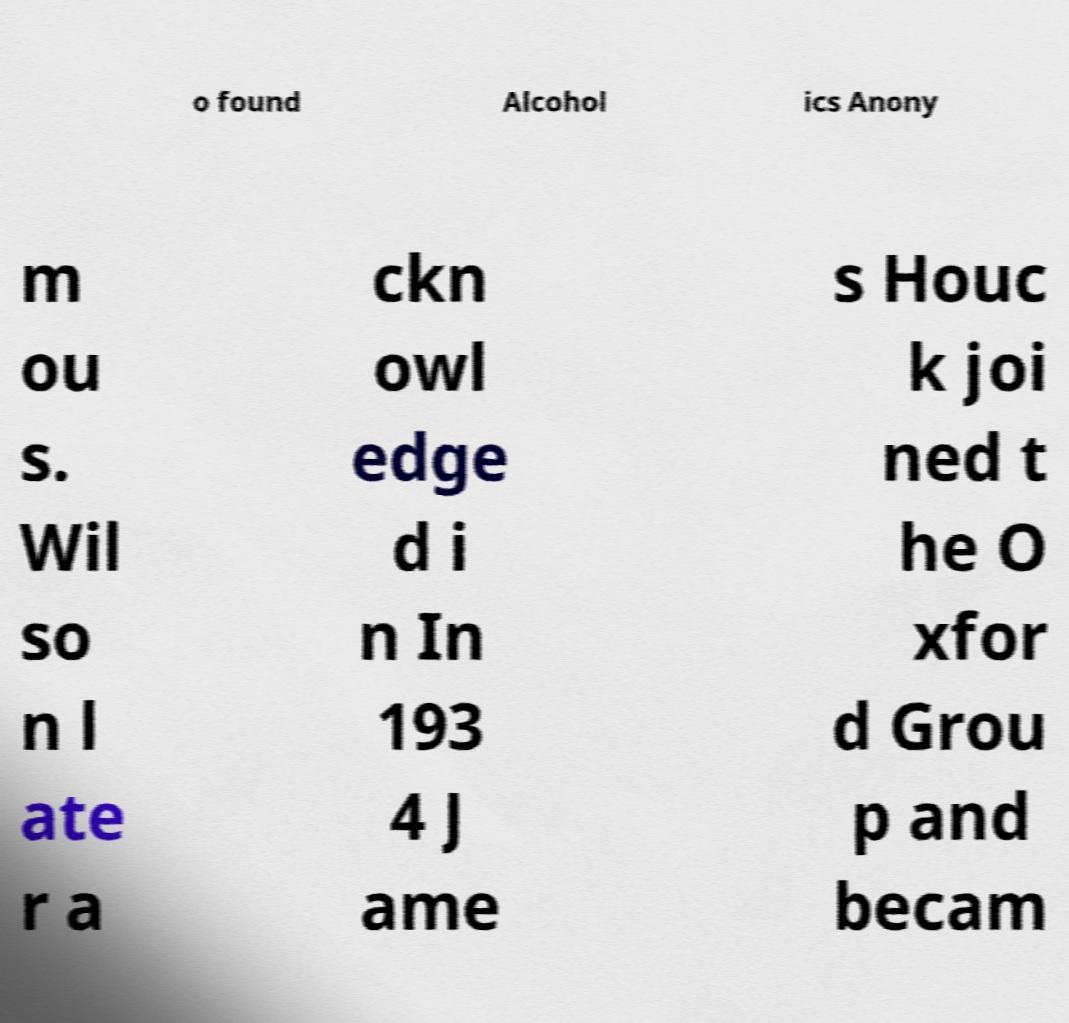Please identify and transcribe the text found in this image. o found Alcohol ics Anony m ou s. Wil so n l ate r a ckn owl edge d i n In 193 4 J ame s Houc k joi ned t he O xfor d Grou p and becam 